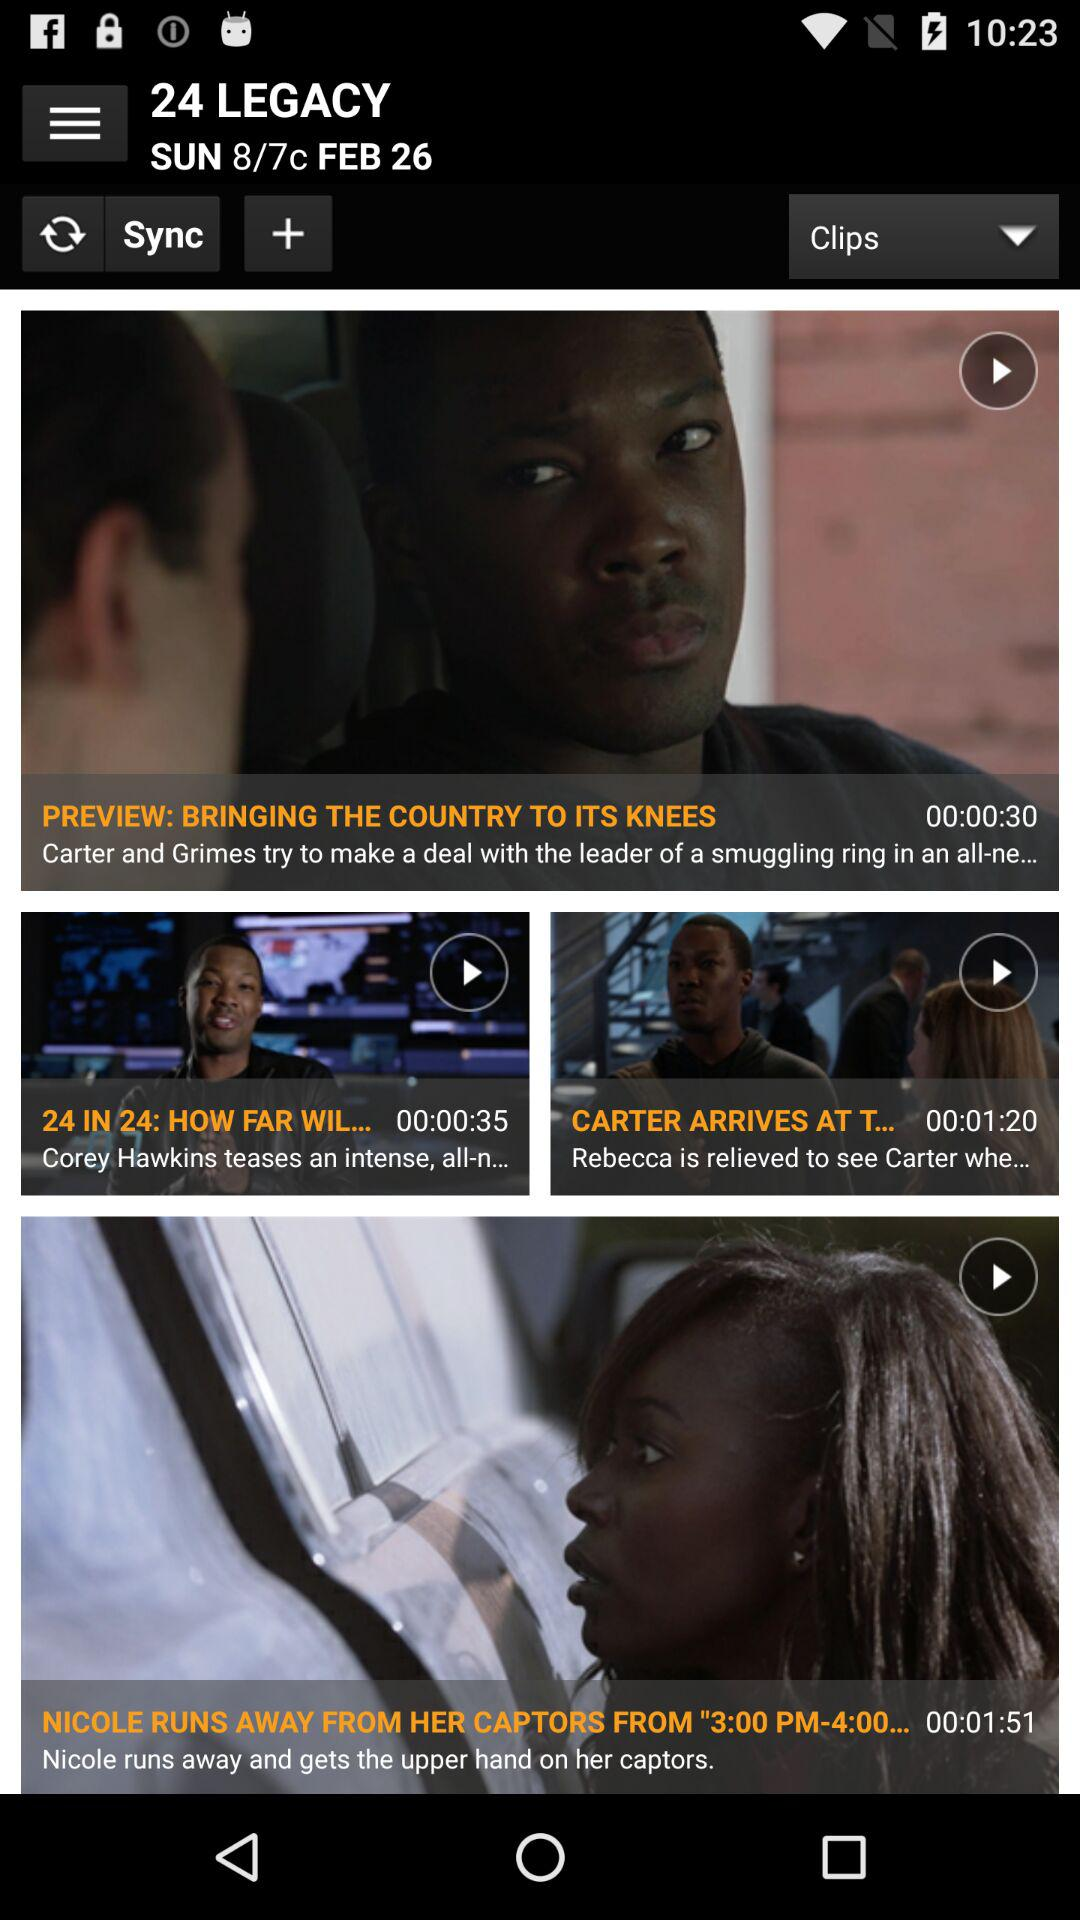On which day was the show telecast? The day is Sunday. 